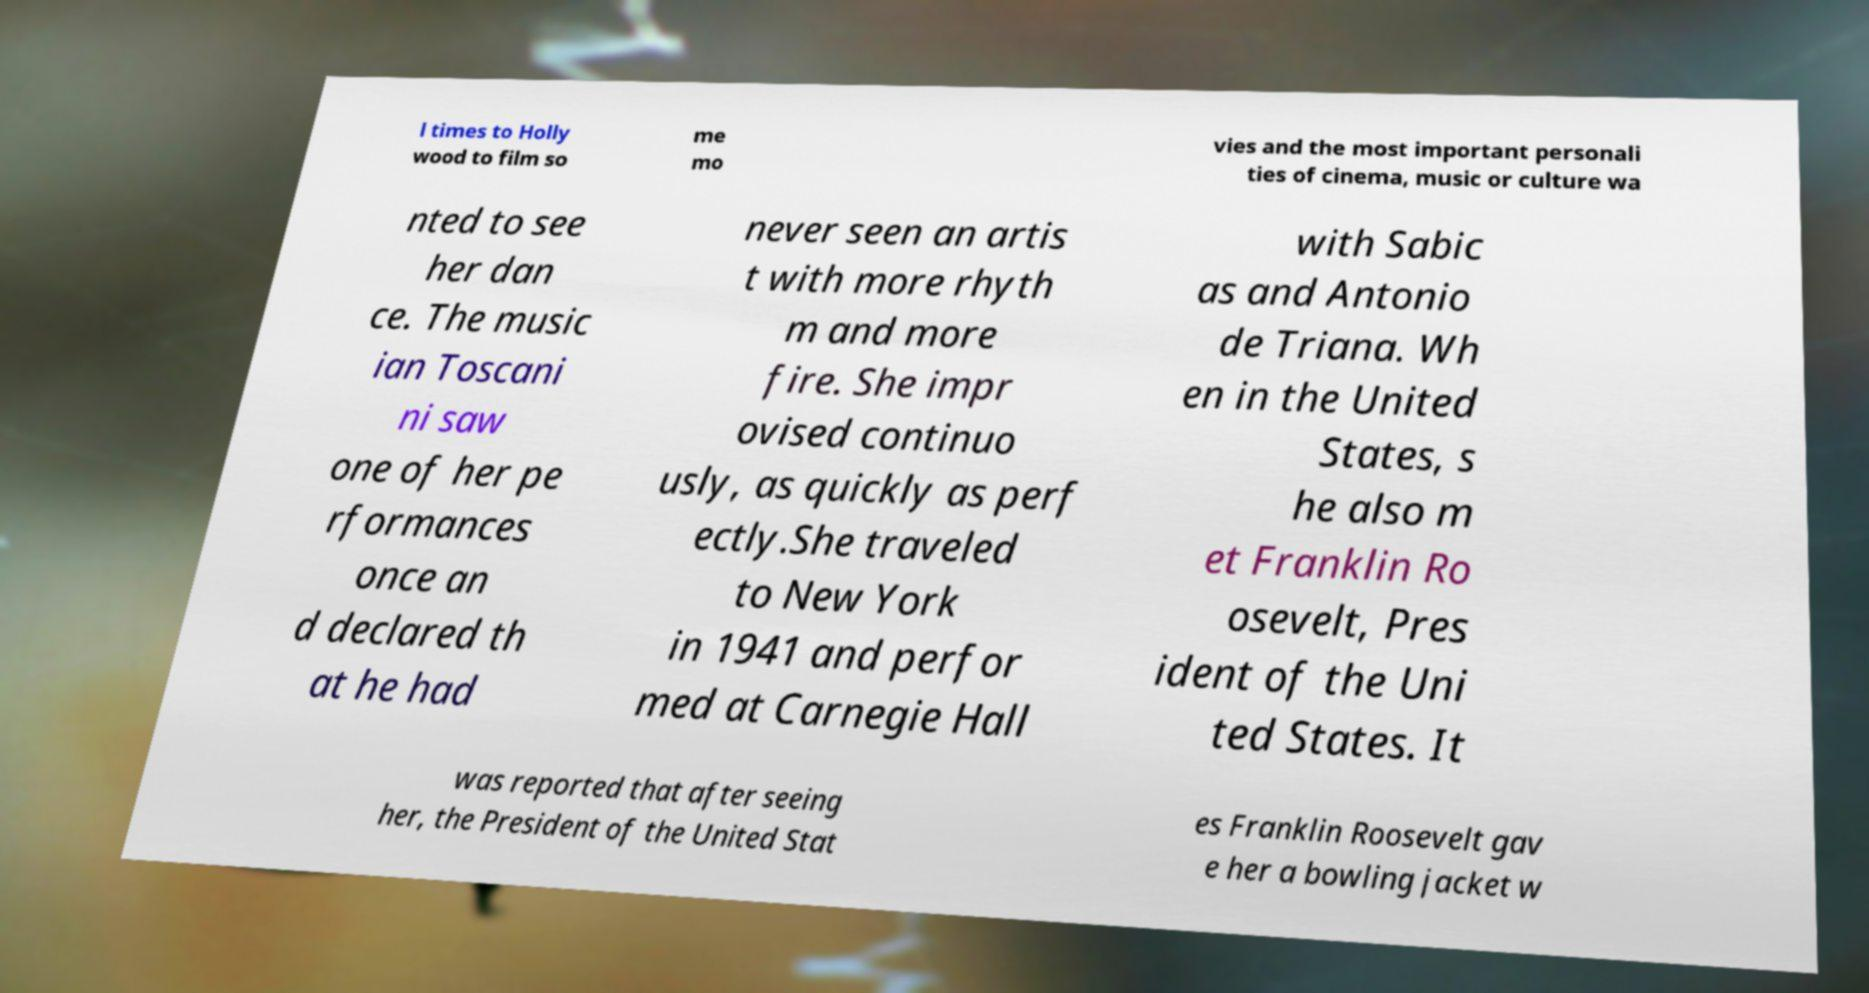What messages or text are displayed in this image? I need them in a readable, typed format. l times to Holly wood to film so me mo vies and the most important personali ties of cinema, music or culture wa nted to see her dan ce. The music ian Toscani ni saw one of her pe rformances once an d declared th at he had never seen an artis t with more rhyth m and more fire. She impr ovised continuo usly, as quickly as perf ectly.She traveled to New York in 1941 and perfor med at Carnegie Hall with Sabic as and Antonio de Triana. Wh en in the United States, s he also m et Franklin Ro osevelt, Pres ident of the Uni ted States. It was reported that after seeing her, the President of the United Stat es Franklin Roosevelt gav e her a bowling jacket w 